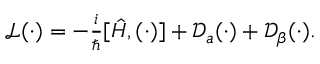<formula> <loc_0><loc_0><loc_500><loc_500>\begin{array} { r } { \mathcal { L } ( \cdot ) = - \frac { i } { } [ \hat { H } , ( \cdot ) ] + \mathcal { D } _ { a } ( \cdot ) + \mathcal { D } _ { \beta } ( \cdot ) . } \end{array}</formula> 